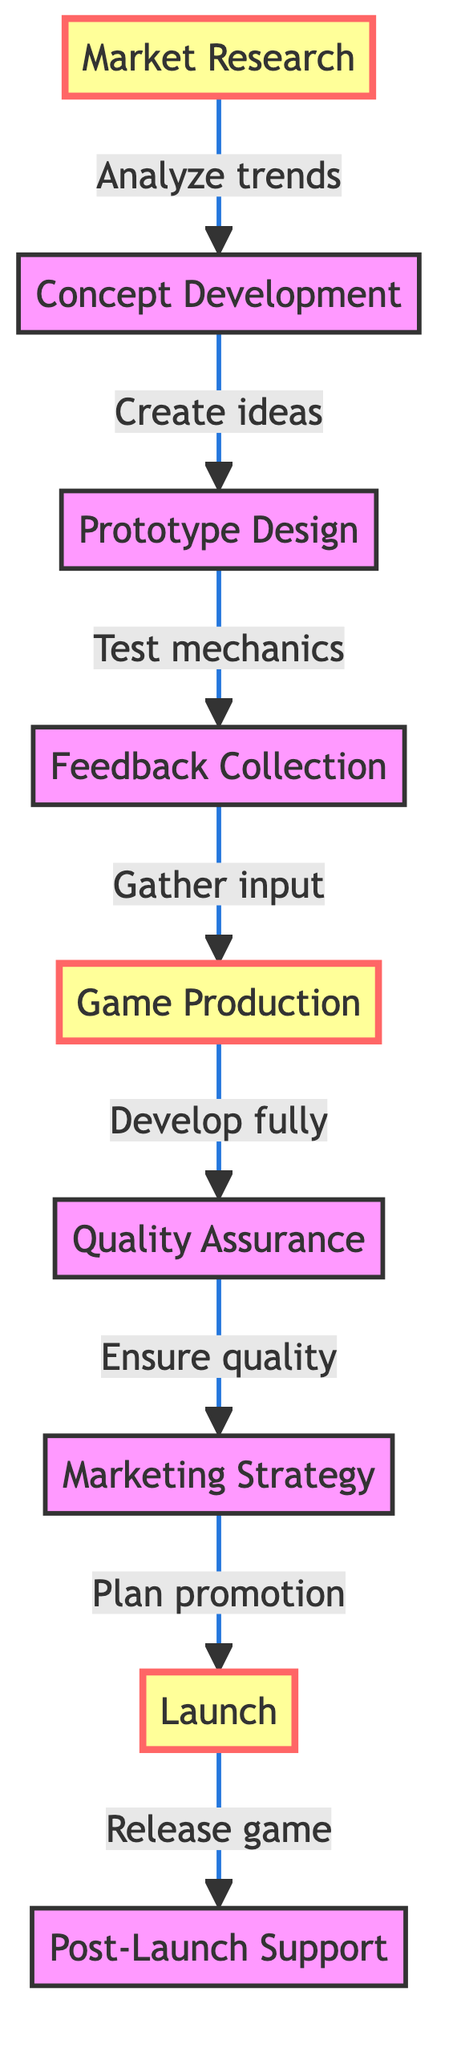What is the first step in the workflow? The first node in the flowchart is "Market Research," which indicates it is the starting point of the game development workflow.
Answer: Market Research How many steps are there in total? By counting all the individual steps represented in the flowchart, including all nodes from "Market Research" to "Post-Launch Support," a total of nine steps is identified.
Answer: 9 Which step follows "Prototype Design"? The flowchart shows an arrow leading from "Prototype Design" to "Feedback Collection," indicating this is the next step in the workflow after designing the prototype.
Answer: Feedback Collection What is the last step in the workflow? The last step, indicated by the final node in the flowchart, is "Post-Launch Support," which shows the ongoing activities after launching the game.
Answer: Post-Launch Support What is the relationship between "Game Production" and "Quality Assurance"? The flowchart indicates a direct connection where "Game Production" leads to "Quality Assurance," meaning that after game production, the next step is to ensure the quality of the game.
Answer: Leads to What do "Marketing Strategy" and "Game Production" have in common in the workflow? Both steps are crucial phases in the workflow, but they serve different purposes; "Game Production" focuses on game creation, while "Marketing Strategy" addresses how to promote it. Despite this, they are both necessary elements before the launch.
Answer: Both are necessary Which step focuses on player feedback? The step that addresses gathering input from players is called "Feedback Collection," which specifically aims to collect feedback from beta testers and focus groups.
Answer: Feedback Collection How does the workflow progress to the marketing phase? After completing "Quality Assurance," the workflow progresses to "Marketing Strategy," demonstrating that ensuring quality is a prerequisite for planning promotions.
Answer: Through Quality Assurance What happens after the launch of the game? After the launch, the workflow leads to "Post-Launch Support," indicating that activities continue after the initial release to engage players and update the game.
Answer: Post-Launch Support 